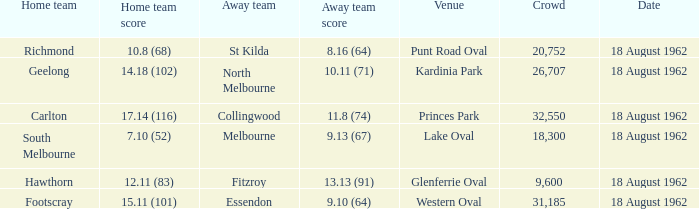8 (68)? Richmond. 